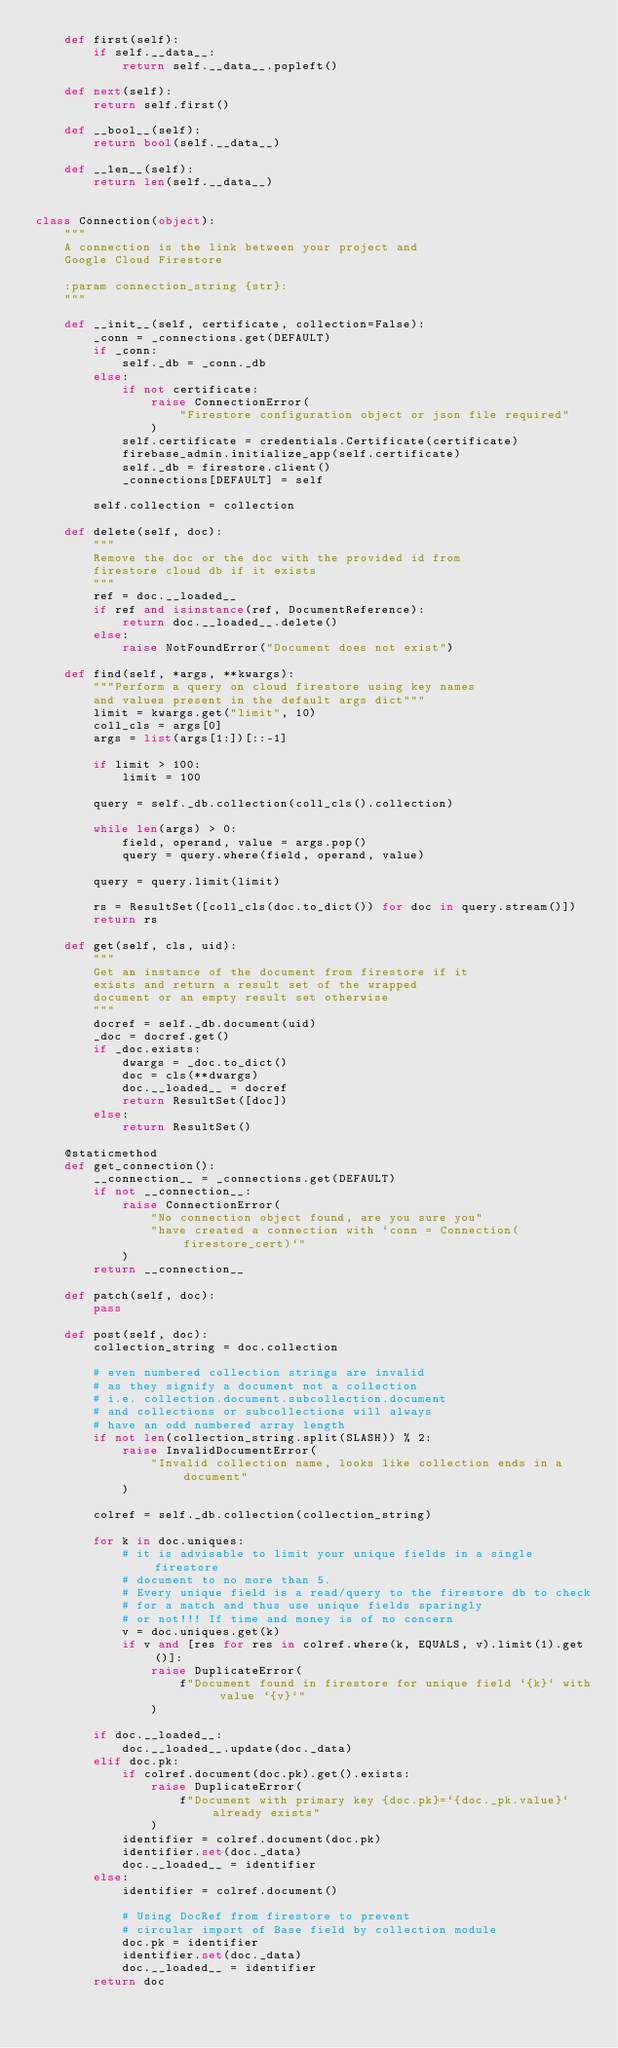Convert code to text. <code><loc_0><loc_0><loc_500><loc_500><_Python_>    def first(self):
        if self.__data__:
            return self.__data__.popleft()

    def next(self):
        return self.first()

    def __bool__(self):
        return bool(self.__data__)

    def __len__(self):
        return len(self.__data__)


class Connection(object):
    """
    A connection is the link between your project and
    Google Cloud Firestore

    :param connection_string {str}:
    """

    def __init__(self, certificate, collection=False):
        _conn = _connections.get(DEFAULT)
        if _conn:
            self._db = _conn._db
        else:
            if not certificate:
                raise ConnectionError(
                    "Firestore configuration object or json file required"
                )
            self.certificate = credentials.Certificate(certificate)
            firebase_admin.initialize_app(self.certificate)
            self._db = firestore.client()
            _connections[DEFAULT] = self

        self.collection = collection

    def delete(self, doc):
        """
        Remove the doc or the doc with the provided id from
        firestore cloud db if it exists
        """
        ref = doc.__loaded__
        if ref and isinstance(ref, DocumentReference):
            return doc.__loaded__.delete()
        else:
            raise NotFoundError("Document does not exist")

    def find(self, *args, **kwargs):
        """Perform a query on cloud firestore using key names
        and values present in the default args dict"""
        limit = kwargs.get("limit", 10)
        coll_cls = args[0]
        args = list(args[1:])[::-1]

        if limit > 100:
            limit = 100

        query = self._db.collection(coll_cls().collection)

        while len(args) > 0:
            field, operand, value = args.pop()
            query = query.where(field, operand, value)

        query = query.limit(limit)

        rs = ResultSet([coll_cls(doc.to_dict()) for doc in query.stream()])
        return rs

    def get(self, cls, uid):
        """
        Get an instance of the document from firestore if it
        exists and return a result set of the wrapped
        document or an empty result set otherwise
        """
        docref = self._db.document(uid)
        _doc = docref.get()
        if _doc.exists:
            dwargs = _doc.to_dict()
            doc = cls(**dwargs)
            doc.__loaded__ = docref
            return ResultSet([doc])
        else:
            return ResultSet()

    @staticmethod
    def get_connection():
        __connection__ = _connections.get(DEFAULT)
        if not __connection__:
            raise ConnectionError(
                "No connection object found, are you sure you"
                "have created a connection with `conn = Connection(firestore_cert)`"
            )
        return __connection__

    def patch(self, doc):
        pass

    def post(self, doc):
        collection_string = doc.collection

        # even numbered collection strings are invalid
        # as they signify a document not a collection
        # i.e. collection.document.subcollection.document
        # and collections or subcollections will always
        # have an odd numbered array length
        if not len(collection_string.split(SLASH)) % 2:
            raise InvalidDocumentError(
                "Invalid collection name, looks like collection ends in a document"
            )

        colref = self._db.collection(collection_string)

        for k in doc.uniques:
            # it is advisable to limit your unique fields in a single firestore
            # document to no more than 5.
            # Every unique field is a read/query to the firestore db to check
            # for a match and thus use unique fields sparingly
            # or not!!! If time and money is of no concern
            v = doc.uniques.get(k)
            if v and [res for res in colref.where(k, EQUALS, v).limit(1).get()]:
                raise DuplicateError(
                    f"Document found in firestore for unique field `{k}` with value `{v}`"
                )

        if doc.__loaded__:
            doc.__loaded__.update(doc._data)
        elif doc.pk:
            if colref.document(doc.pk).get().exists:
                raise DuplicateError(
                    f"Document with primary key {doc.pk}=`{doc._pk.value}` already exists"
                )
            identifier = colref.document(doc.pk)
            identifier.set(doc._data)
            doc.__loaded__ = identifier
        else:
            identifier = colref.document()

            # Using DocRef from firestore to prevent
            # circular import of Base field by collection module
            doc.pk = identifier
            identifier.set(doc._data)
            doc.__loaded__ = identifier
        return doc
</code> 